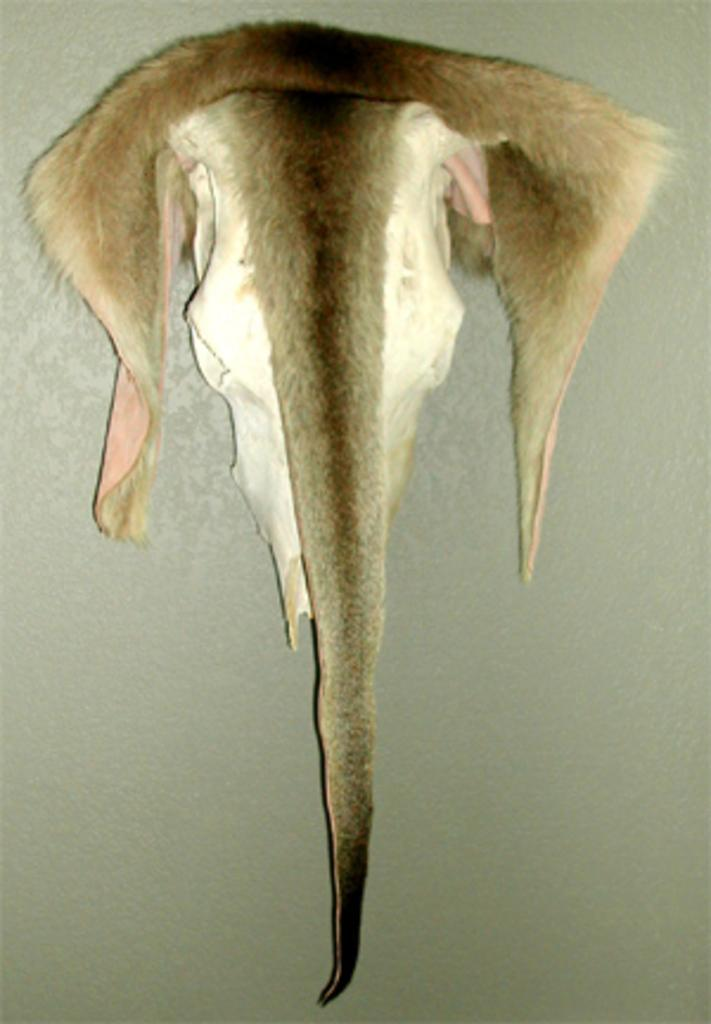What type of object is featured in the image? The image contains the skin of an animal. How is the animal skin positioned in the image? The animal skin is hanged on the wall. What type of snails can be seen crawling on the animal skin in the image? There are no snails present in the image. What type of fowl can be seen perched on the animal skin in the image? There are no fowl present in the image. What type of vehicle can be seen parked next to the animal skin in the image? There is no vehicle present in the image. 